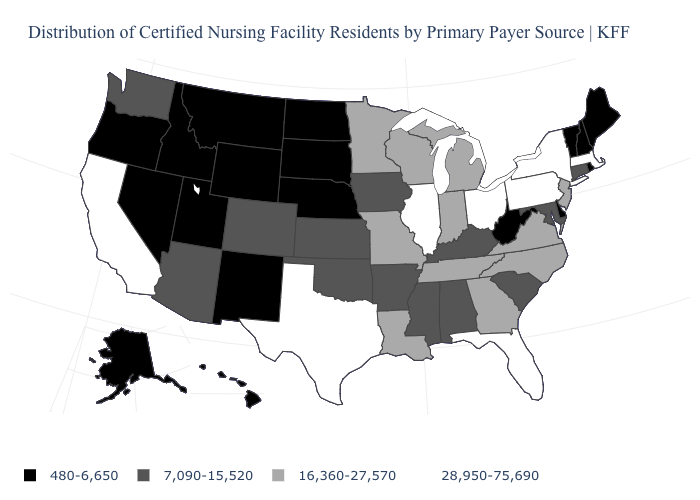Name the states that have a value in the range 7,090-15,520?
Answer briefly. Alabama, Arizona, Arkansas, Colorado, Connecticut, Iowa, Kansas, Kentucky, Maryland, Mississippi, Oklahoma, South Carolina, Washington. What is the value of New Hampshire?
Short answer required. 480-6,650. Does the map have missing data?
Keep it brief. No. What is the value of Alaska?
Write a very short answer. 480-6,650. What is the value of Illinois?
Answer briefly. 28,950-75,690. What is the lowest value in the USA?
Keep it brief. 480-6,650. Name the states that have a value in the range 480-6,650?
Answer briefly. Alaska, Delaware, Hawaii, Idaho, Maine, Montana, Nebraska, Nevada, New Hampshire, New Mexico, North Dakota, Oregon, Rhode Island, South Dakota, Utah, Vermont, West Virginia, Wyoming. What is the highest value in the USA?
Write a very short answer. 28,950-75,690. What is the value of Washington?
Answer briefly. 7,090-15,520. Which states have the lowest value in the USA?
Be succinct. Alaska, Delaware, Hawaii, Idaho, Maine, Montana, Nebraska, Nevada, New Hampshire, New Mexico, North Dakota, Oregon, Rhode Island, South Dakota, Utah, Vermont, West Virginia, Wyoming. How many symbols are there in the legend?
Answer briefly. 4. What is the lowest value in states that border Alabama?
Answer briefly. 7,090-15,520. Name the states that have a value in the range 16,360-27,570?
Keep it brief. Georgia, Indiana, Louisiana, Michigan, Minnesota, Missouri, New Jersey, North Carolina, Tennessee, Virginia, Wisconsin. What is the lowest value in the MidWest?
Concise answer only. 480-6,650. Does the first symbol in the legend represent the smallest category?
Quick response, please. Yes. 